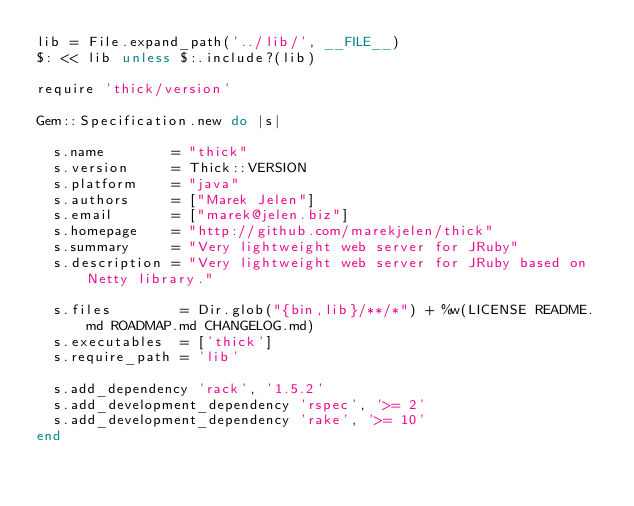Convert code to text. <code><loc_0><loc_0><loc_500><loc_500><_Ruby_>lib = File.expand_path('../lib/', __FILE__)
$: << lib unless $:.include?(lib)

require 'thick/version'

Gem::Specification.new do |s|

  s.name        = "thick"
  s.version     = Thick::VERSION
  s.platform    = "java"
  s.authors     = ["Marek Jelen"]
  s.email       = ["marek@jelen.biz"]
  s.homepage    = "http://github.com/marekjelen/thick"
  s.summary     = "Very lightweight web server for JRuby"
  s.description = "Very lightweight web server for JRuby based on Netty library."

  s.files        = Dir.glob("{bin,lib}/**/*") + %w(LICENSE README.md ROADMAP.md CHANGELOG.md)
  s.executables  = ['thick']
  s.require_path = 'lib'

  s.add_dependency 'rack', '1.5.2'
  s.add_development_dependency 'rspec', '>= 2'
  s.add_development_dependency 'rake', '>= 10'
end</code> 